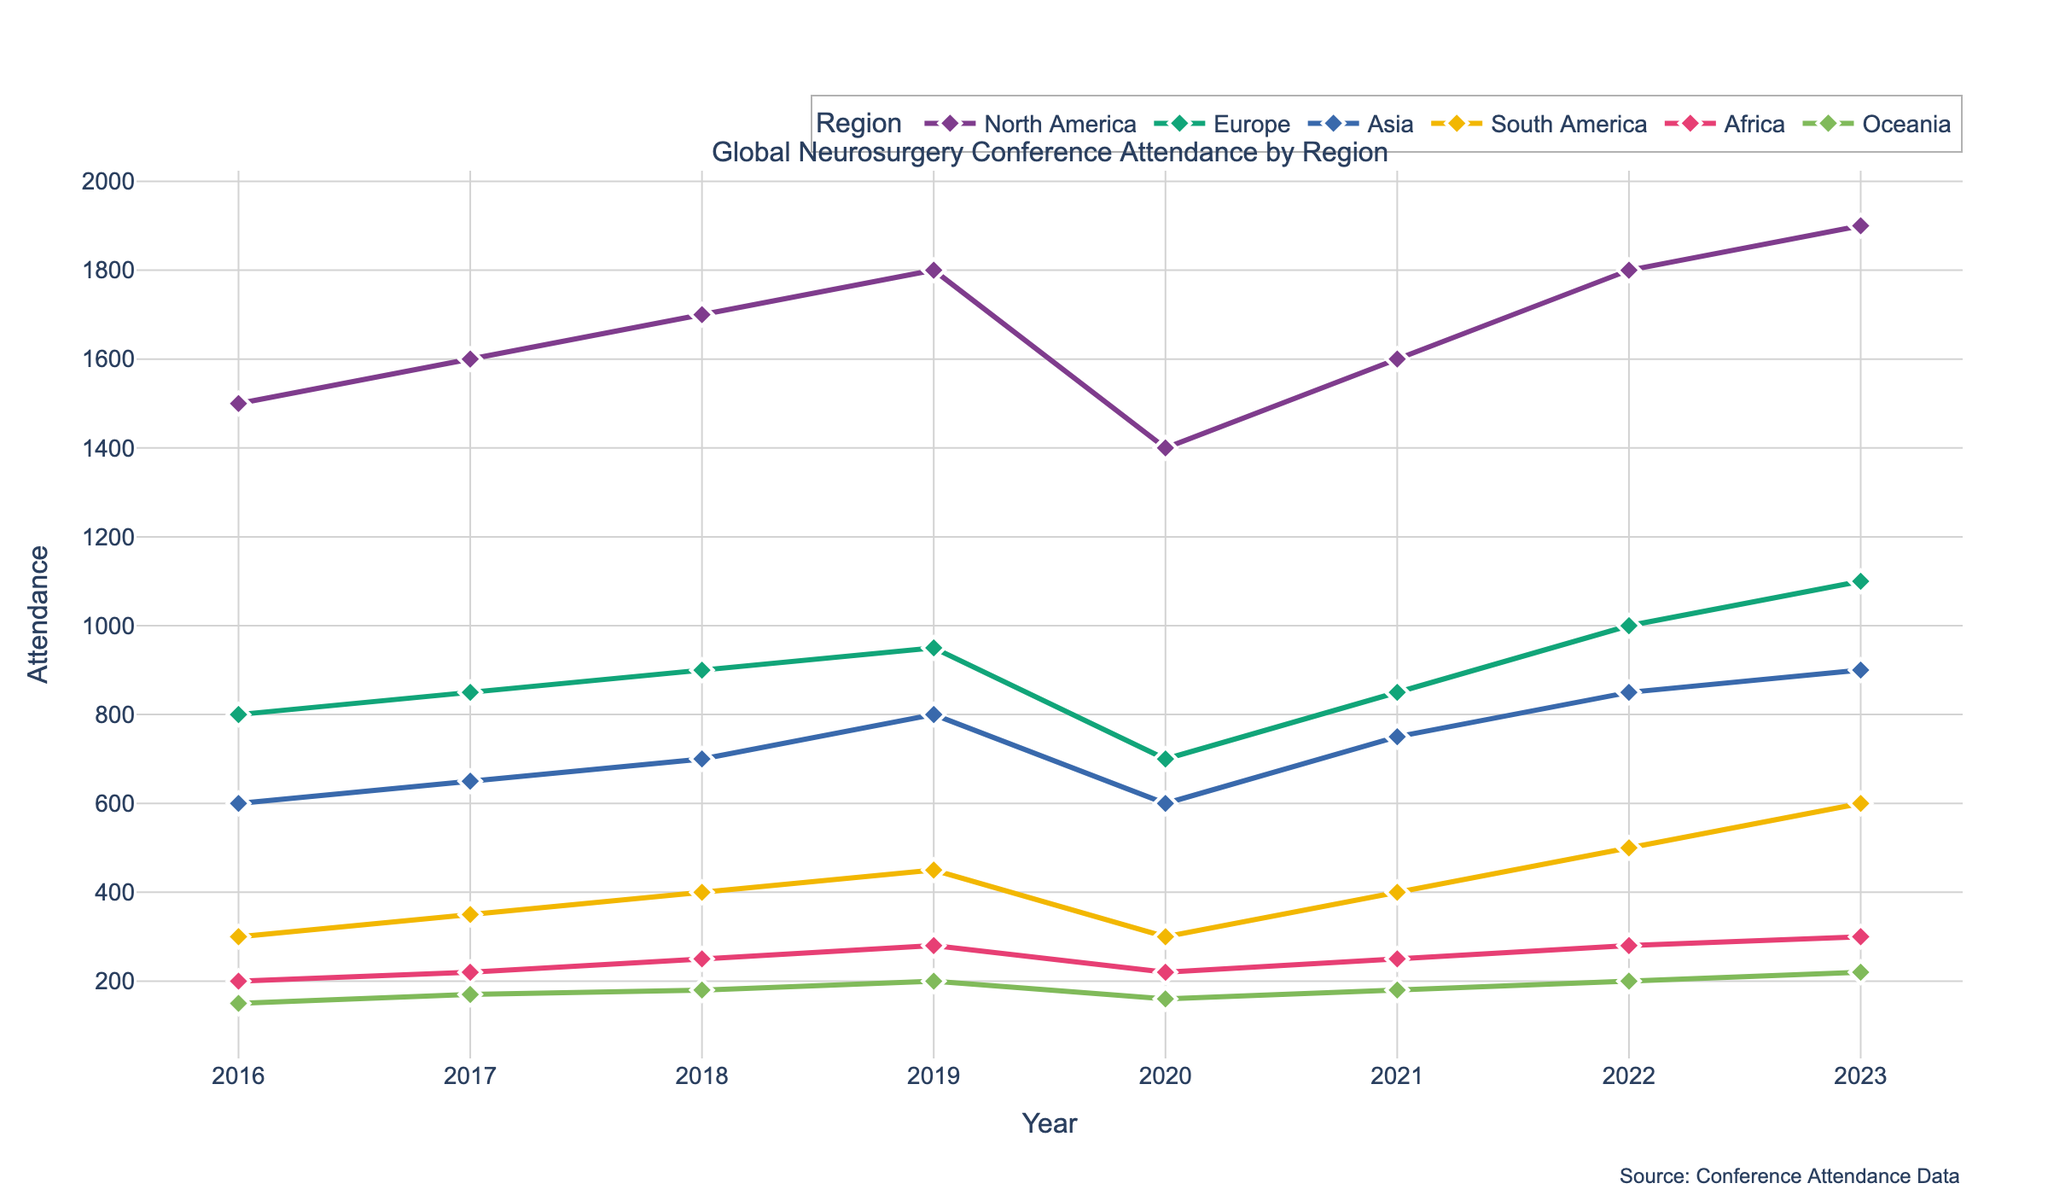What is the title of the figure? The title is usually found at the top of the figure. It provides a summary of what the figure represents. Here, the title is "Global Neurosurgery Conference Attendance by Region."
Answer: Global Neurosurgery Conference Attendance by Region How many regions are represented in the figure? Count the number of unique lines in the plot, each line represents a region. Here, there are six lines.
Answer: Six Which region had the highest attendance in 2023? Locate the year 2023 on the x-axis and follow each line to see the y-value at that point. North America has the highest value.
Answer: North America Did any region have a decrease in attendance between two consecutive years? Check each line for any downward slope between consecutive years. North America, Europe, Asia, South America, and Oceania all show a decrease in 2020 compared to 2019.
Answer: Yes What is the overall trend in attendance for the Asia region from 2016 to 2023? Follow the line for Asia from 2016 to 2023. The line generally trends upwards, indicating an increase in attendance over the years.
Answer: Increasing By how much did the attendance for Europe change from 2019 to 2020? Locate the values for Europe in 2019 and 2020 and subtract to find the difference. The attendance in 2019 was 950 and in 2020 was 700, so the change is 950 - 700.
Answer: 250 Which year had the overall lowest attendance across all regions? Visually inspect for the lowest point on each line and note the corresponding year. The points in 2020 are generally the lowest.
Answer: 2020 Compare the growth in attendance from 2016 to 2023 between North America and Asia. Which region had a higher increase? Subtract the 2016 attendance from the 2023 attendance for both regions and compare. North America's attendance increased from 1500 to 1900, and Asia's attendance increased from 600 to 900.
Answer: North America What is the attendance trend for Oceania region after 2020? Identify the trend of the line for Oceania starting from 2020 onwards. The line trends upwards after a drop in 2020.
Answer: Increasing Between 2021 and 2023, which region had the most consistent attendance numbers? Compare the lines between 2021 and 2023 and see which has the least variation. Africa's line is relatively flat during this period.
Answer: Africa 